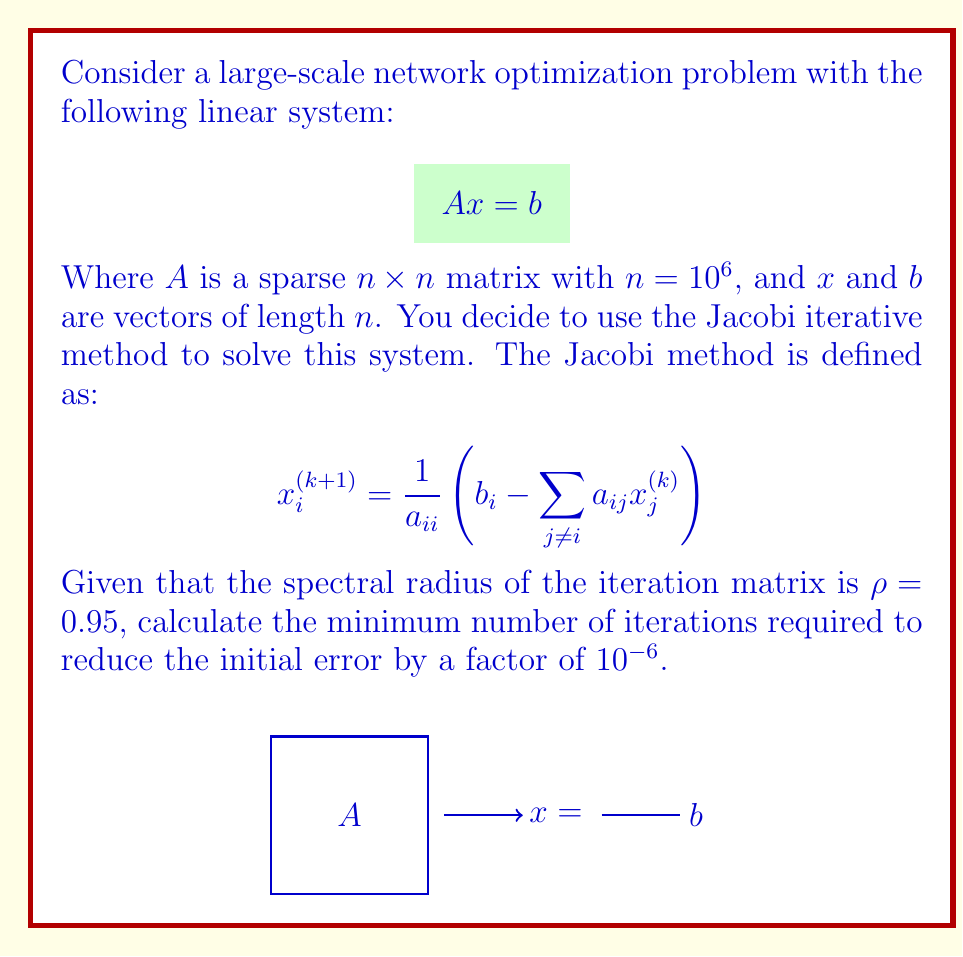Show me your answer to this math problem. Let's approach this step-by-step:

1) The convergence rate of the Jacobi method is determined by the spectral radius $\rho$ of the iteration matrix. We're given that $\rho = 0.95$.

2) For iterative methods, the error at iteration $k$ is bounded by:

   $$\|e^{(k)}\| \leq \rho^k \|e^{(0)}\|$$

   where $e^{(k)}$ is the error at iteration $k$ and $e^{(0)}$ is the initial error.

3) We want to reduce the error by a factor of $10^{-6}$, which means:

   $$\frac{\|e^{(k)}\|}{\|e^{(0)}\|} \leq 10^{-6}$$

4) Combining steps 2 and 3:

   $$\rho^k \leq 10^{-6}$$

5) Taking the logarithm of both sides:

   $$k \log \rho \leq \log(10^{-6})$$

6) Solving for $k$:

   $$k \geq \frac{\log(10^{-6})}{\log \rho}$$

7) Plugging in $\rho = 0.95$:

   $$k \geq \frac{\log(10^{-6})}{\log 0.95} \approx 281.54$$

8) Since $k$ must be an integer, we round up to the nearest whole number.

Therefore, the minimum number of iterations required is 282.
Answer: 282 iterations 